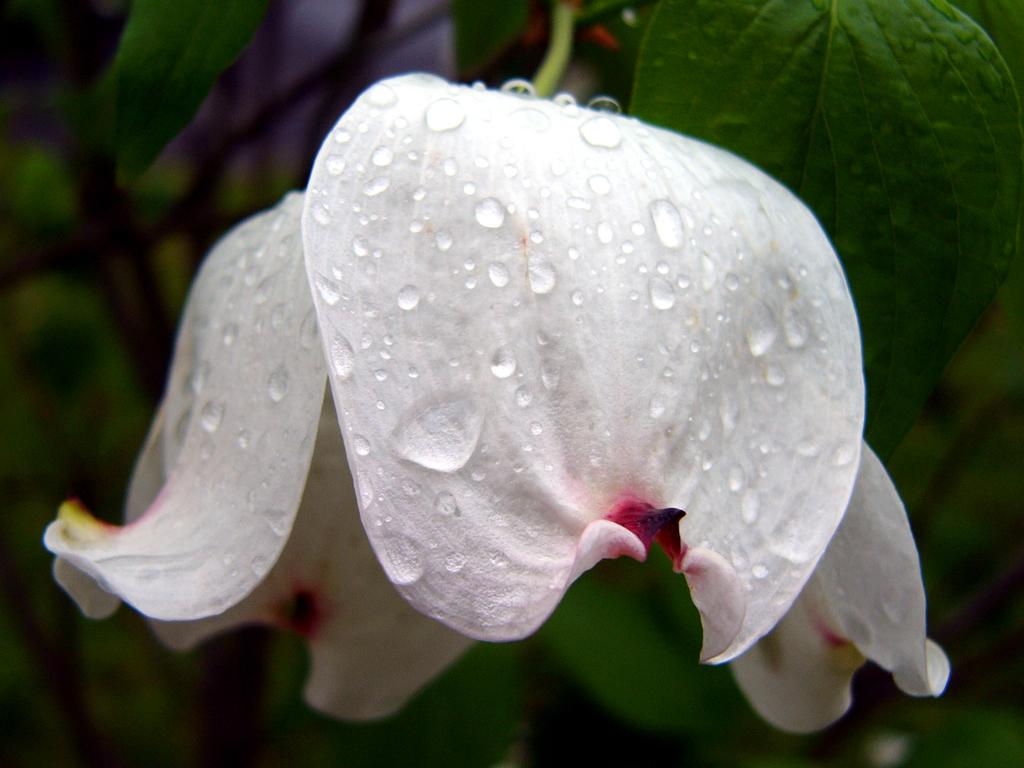What type of flower is in the image? There is a white flower in the image. Can you describe the condition of the flower? There are water drops on the flower. What else can be seen in the background of the image? Leaves are visible in the background of the image. How many dogs are visible in the image? There are no dogs present in the image; it features a white flower with water drops and leaves in the background. What type of fear can be observed in the ants in the image? There are no ants present in the image, so it is not possible to determine if they are experiencing any fear. 